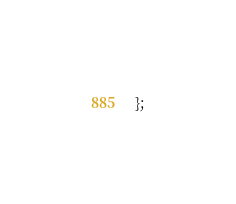Convert code to text. <code><loc_0><loc_0><loc_500><loc_500><_JavaScript_>};
</code> 